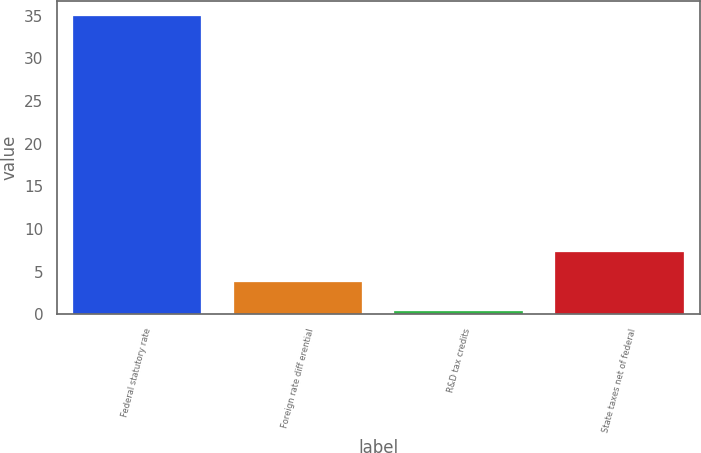Convert chart. <chart><loc_0><loc_0><loc_500><loc_500><bar_chart><fcel>Federal statutory rate<fcel>Foreign rate diff erential<fcel>R&D tax credits<fcel>State taxes net of federal<nl><fcel>35<fcel>3.82<fcel>0.36<fcel>7.28<nl></chart> 